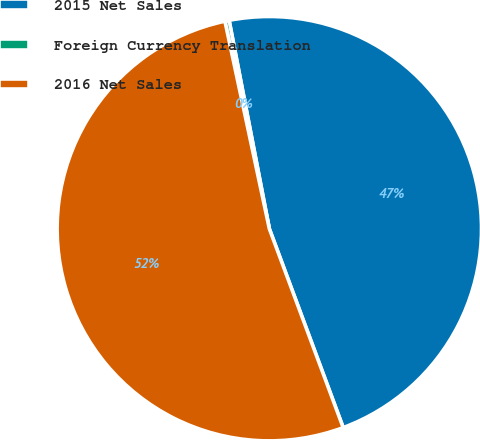Convert chart to OTSL. <chart><loc_0><loc_0><loc_500><loc_500><pie_chart><fcel>2015 Net Sales<fcel>Foreign Currency Translation<fcel>2016 Net Sales<nl><fcel>47.38%<fcel>0.32%<fcel>52.31%<nl></chart> 